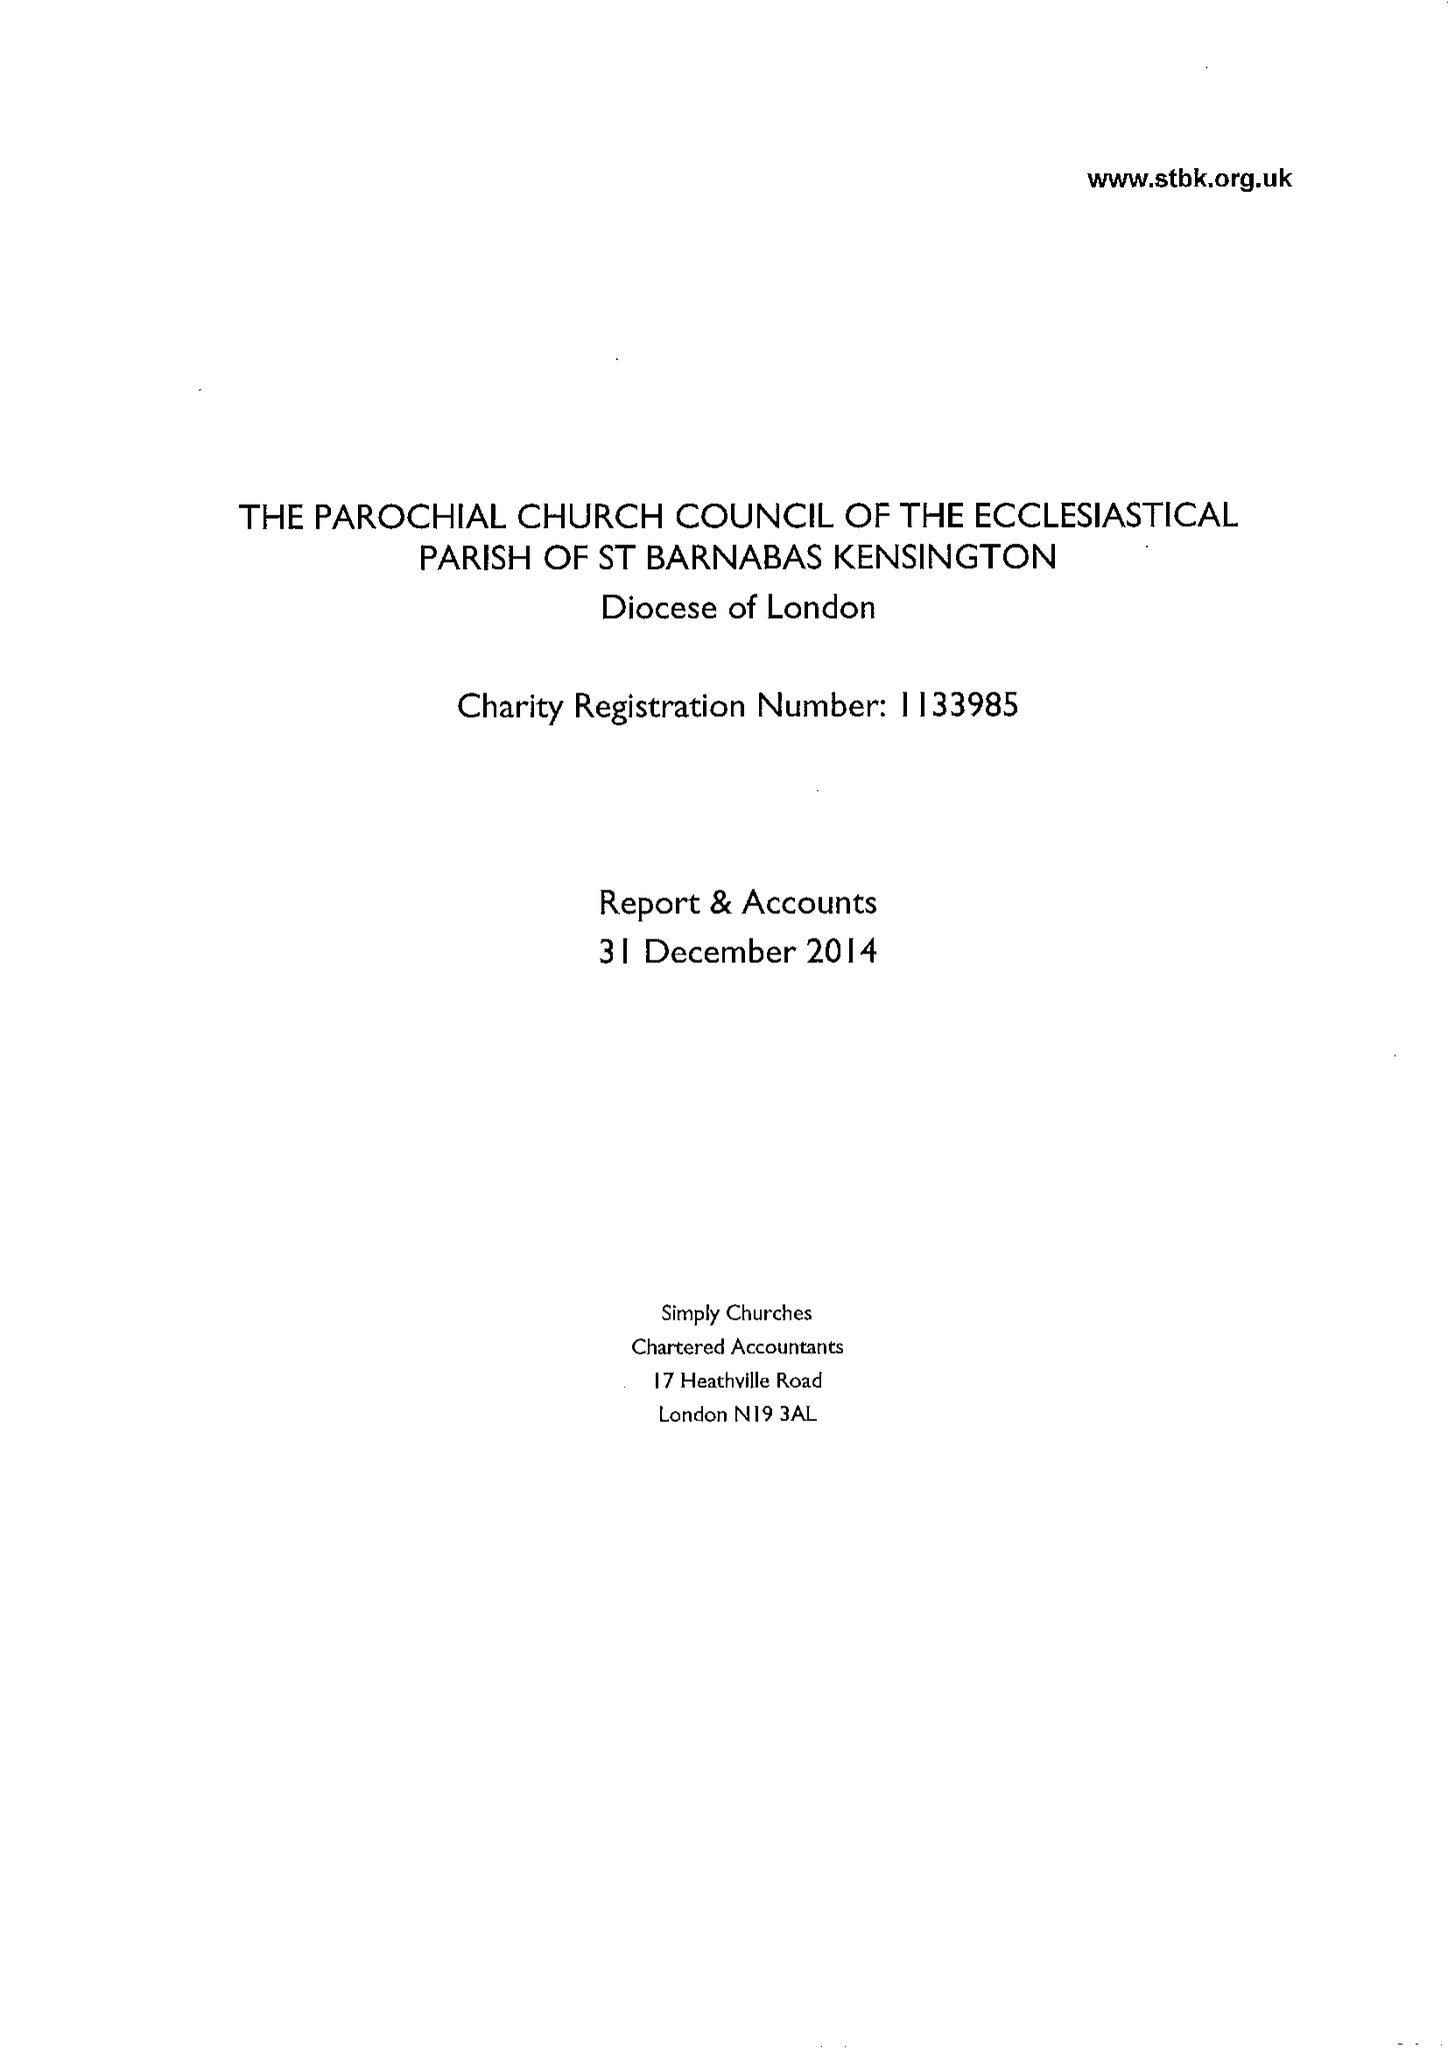What is the value for the address__street_line?
Answer the question using a single word or phrase. 23 ADDISON ROAD 